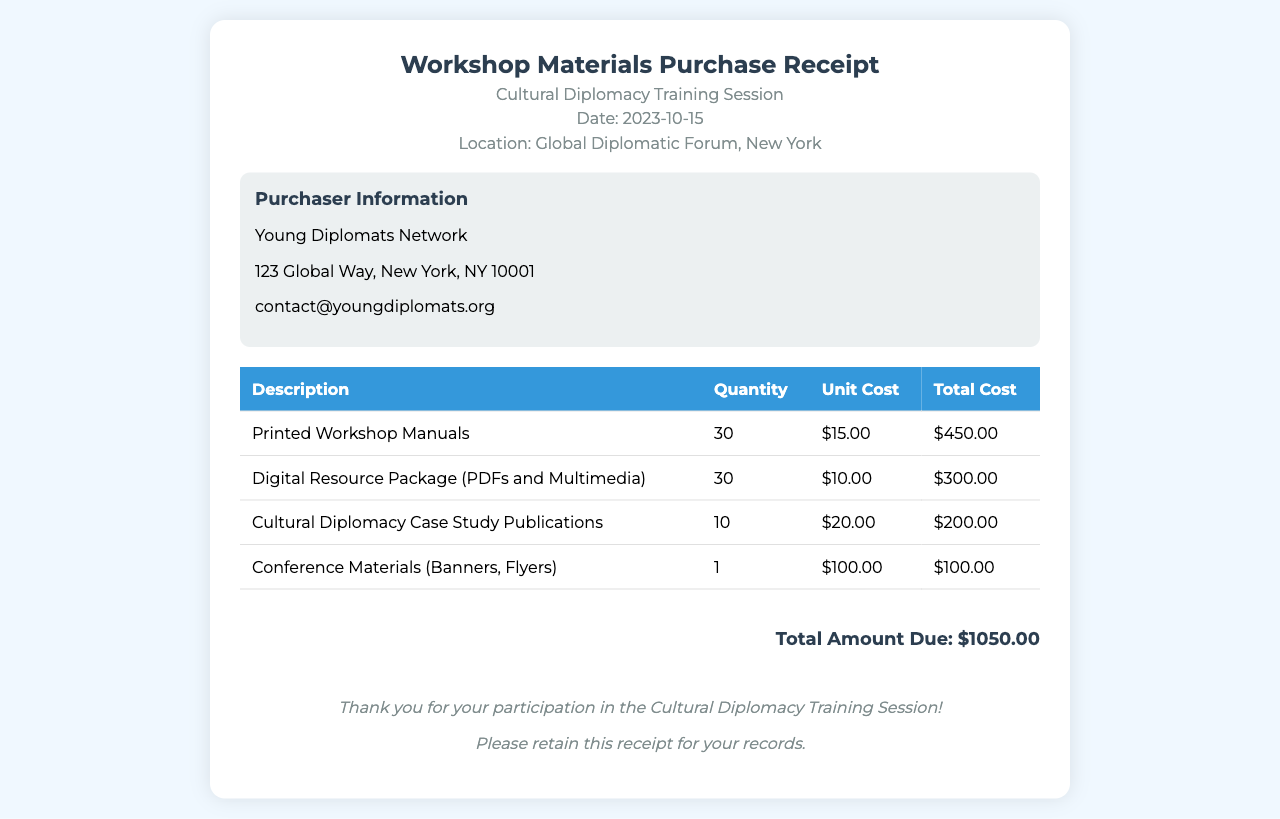What is the total amount due? The total amount due is listed at the bottom of the receipt, summarizing the costs of all items purchased.
Answer: $1050.00 What is the date of the training session? The date is prominently displayed in the header of the receipt.
Answer: 2023-10-15 How many printed workshop manuals were purchased? The quantity of printed workshop manuals is specified in the itemized table.
Answer: 30 Who is the purchaser? The purchaser is identified in the purchaser information section of the receipt.
Answer: Young Diplomats Network What is the cost of the digital resource package? The unit cost of the digital resource package is given in the itemized section of the receipt.
Answer: $300.00 How many cultural diplomacy case study publications were bought? The quantity of cultural diplomacy case study publications is indicated in the itemized table.
Answer: 10 What type of materials were included in the conference materials? The conference materials description specifies the types provided on the receipt.
Answer: Banners, Flyers What is the unit cost of the printed workshop manuals? The unit cost is listed next to the item description in the table.
Answer: $15.00 Where was the training session located? The location of the training session is mentioned in the header of the receipt.
Answer: Global Diplomatic Forum, New York 